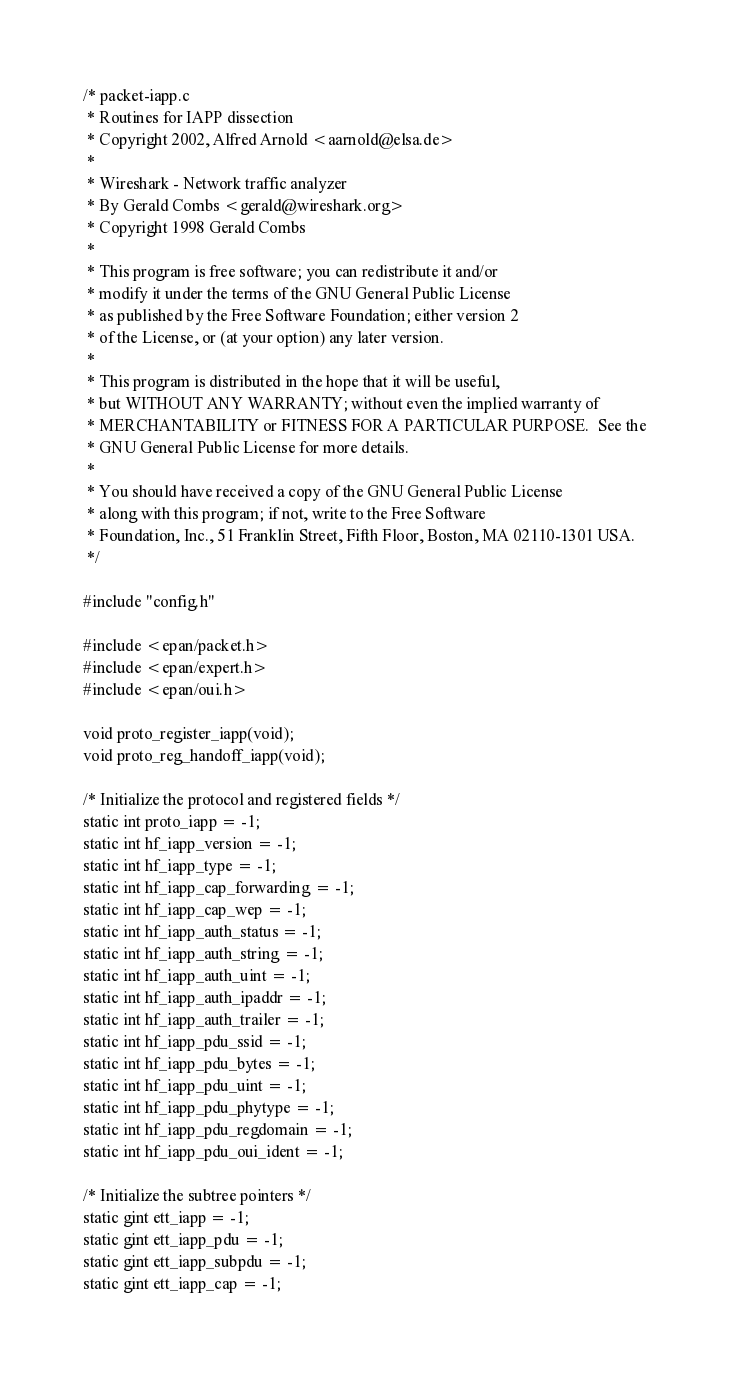<code> <loc_0><loc_0><loc_500><loc_500><_C_>/* packet-iapp.c
 * Routines for IAPP dissection
 * Copyright 2002, Alfred Arnold <aarnold@elsa.de>
 *
 * Wireshark - Network traffic analyzer
 * By Gerald Combs <gerald@wireshark.org>
 * Copyright 1998 Gerald Combs
 *
 * This program is free software; you can redistribute it and/or
 * modify it under the terms of the GNU General Public License
 * as published by the Free Software Foundation; either version 2
 * of the License, or (at your option) any later version.
 *
 * This program is distributed in the hope that it will be useful,
 * but WITHOUT ANY WARRANTY; without even the implied warranty of
 * MERCHANTABILITY or FITNESS FOR A PARTICULAR PURPOSE.  See the
 * GNU General Public License for more details.
 *
 * You should have received a copy of the GNU General Public License
 * along with this program; if not, write to the Free Software
 * Foundation, Inc., 51 Franklin Street, Fifth Floor, Boston, MA 02110-1301 USA.
 */

#include "config.h"

#include <epan/packet.h>
#include <epan/expert.h>
#include <epan/oui.h>

void proto_register_iapp(void);
void proto_reg_handoff_iapp(void);

/* Initialize the protocol and registered fields */
static int proto_iapp = -1;
static int hf_iapp_version = -1;
static int hf_iapp_type = -1;
static int hf_iapp_cap_forwarding = -1;
static int hf_iapp_cap_wep = -1;
static int hf_iapp_auth_status = -1;
static int hf_iapp_auth_string = -1;
static int hf_iapp_auth_uint = -1;
static int hf_iapp_auth_ipaddr = -1;
static int hf_iapp_auth_trailer = -1;
static int hf_iapp_pdu_ssid = -1;
static int hf_iapp_pdu_bytes = -1;
static int hf_iapp_pdu_uint = -1;
static int hf_iapp_pdu_phytype = -1;
static int hf_iapp_pdu_regdomain = -1;
static int hf_iapp_pdu_oui_ident = -1;

/* Initialize the subtree pointers */
static gint ett_iapp = -1;
static gint ett_iapp_pdu = -1;
static gint ett_iapp_subpdu = -1;
static gint ett_iapp_cap = -1;</code> 